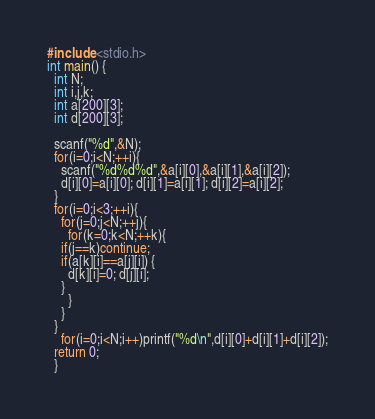<code> <loc_0><loc_0><loc_500><loc_500><_C_>#include <stdio.h>
int main() {
  int N;
  int i,j,k;
  int a[200][3];
  int d[200][3];
  
  scanf("%d",&N);
  for(i=0;i<N;++i){
    scanf("%d%d%d",&a[i][0],&a[i][1],&a[i][2]);
    d[i][0]=a[i][0]; d[i][1]=a[i][1]; d[i][2]=a[i][2];
  }
  for(i=0;i<3;++i){
    for(j=0;j<N;++j){
      for(k=0;k<N;++k){
	if(j==k)continue;
	if(a[k][i]==a[j][i]) {
	  d[k][i]=0; d[j][i];
	}
      }
    }
  }
    for(i=0;i<N;i++)printf("%d\n",d[i][0]+d[i][1]+d[i][2]);
  return 0;
  }</code> 